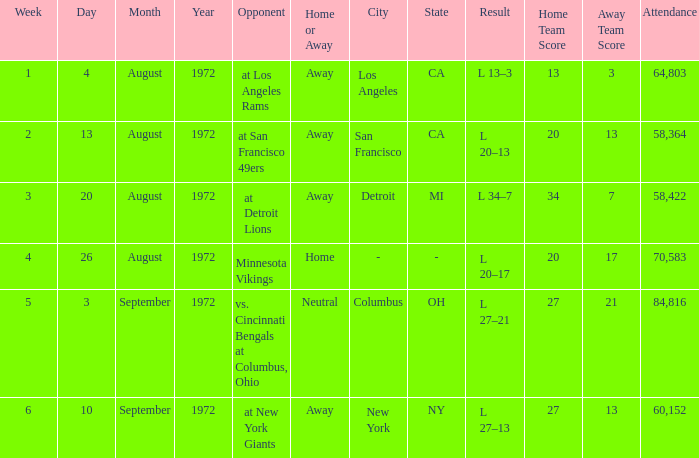How many weeks had an attendance larger than 84,816? 0.0. 